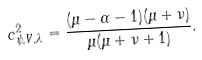Convert formula to latex. <formula><loc_0><loc_0><loc_500><loc_500>c ^ { 2 } _ { \psi , V , \lambda } = \frac { ( \mu - \alpha - 1 ) ( \mu + \nu ) } { \mu ( \mu + \nu + 1 ) } .</formula> 